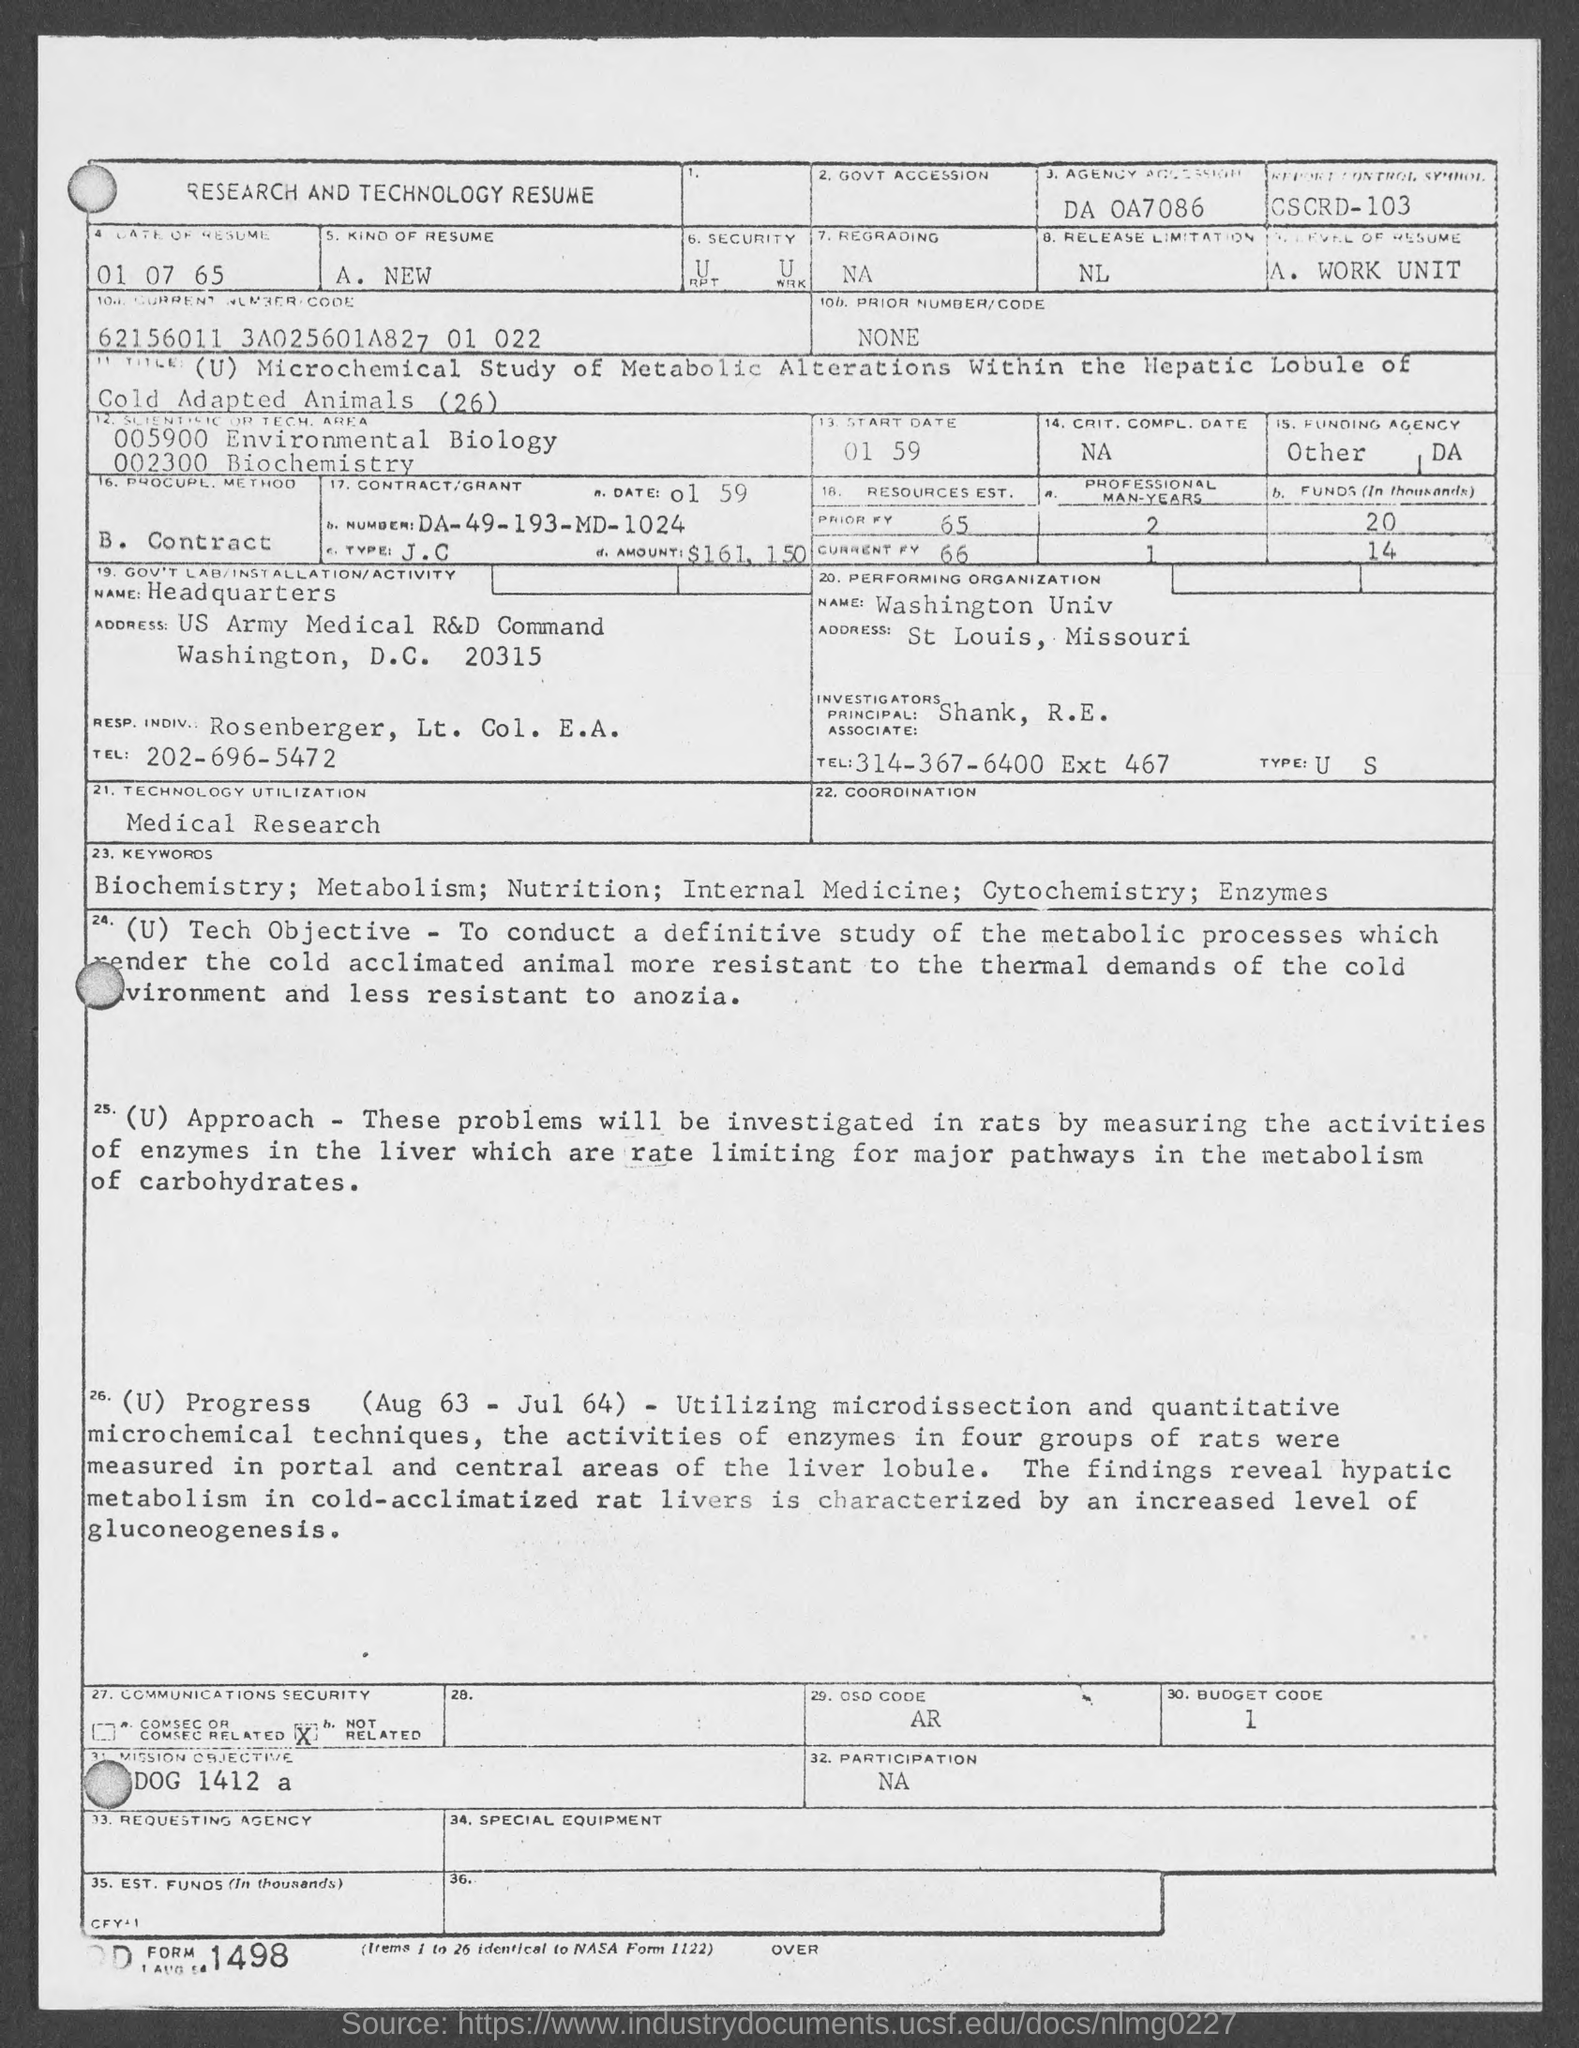What is the date of resume mentioned in the document?
Keep it short and to the point. 01 07 65. Who is the Principal Investigator given in the resume?
Keep it short and to the point. Shank , R.E. What is the Contract No. given in the resume?
Make the answer very short. DA-49-193-MD-1024. Which is the performing organization as per the resume?
Ensure brevity in your answer.  Washington Univ. 